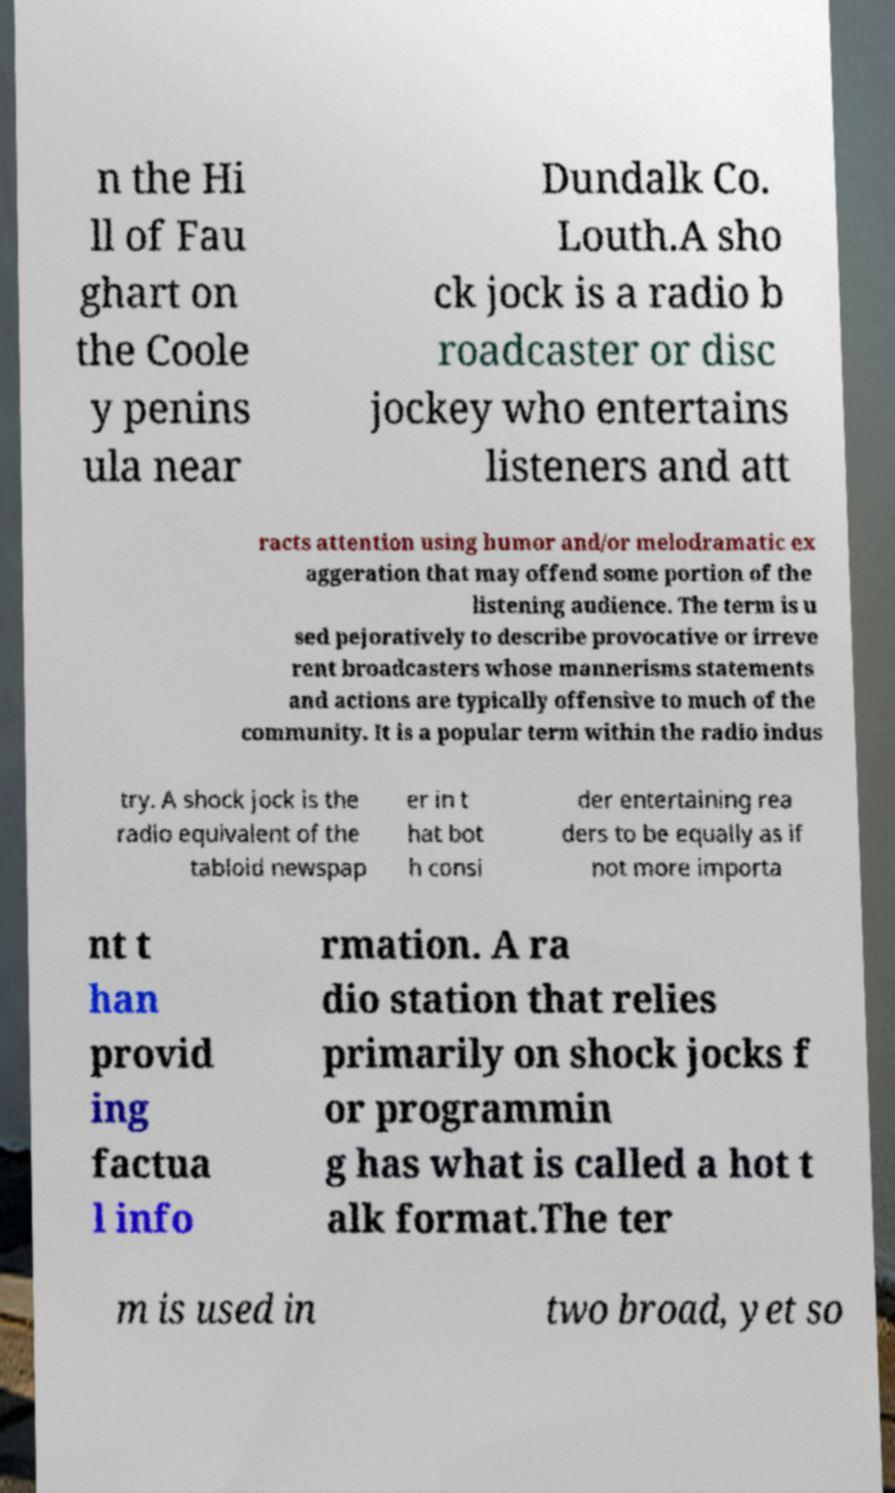For documentation purposes, I need the text within this image transcribed. Could you provide that? n the Hi ll of Fau ghart on the Coole y penins ula near Dundalk Co. Louth.A sho ck jock is a radio b roadcaster or disc jockey who entertains listeners and att racts attention using humor and/or melodramatic ex aggeration that may offend some portion of the listening audience. The term is u sed pejoratively to describe provocative or irreve rent broadcasters whose mannerisms statements and actions are typically offensive to much of the community. It is a popular term within the radio indus try. A shock jock is the radio equivalent of the tabloid newspap er in t hat bot h consi der entertaining rea ders to be equally as if not more importa nt t han provid ing factua l info rmation. A ra dio station that relies primarily on shock jocks f or programmin g has what is called a hot t alk format.The ter m is used in two broad, yet so 